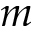<formula> <loc_0><loc_0><loc_500><loc_500>m</formula> 